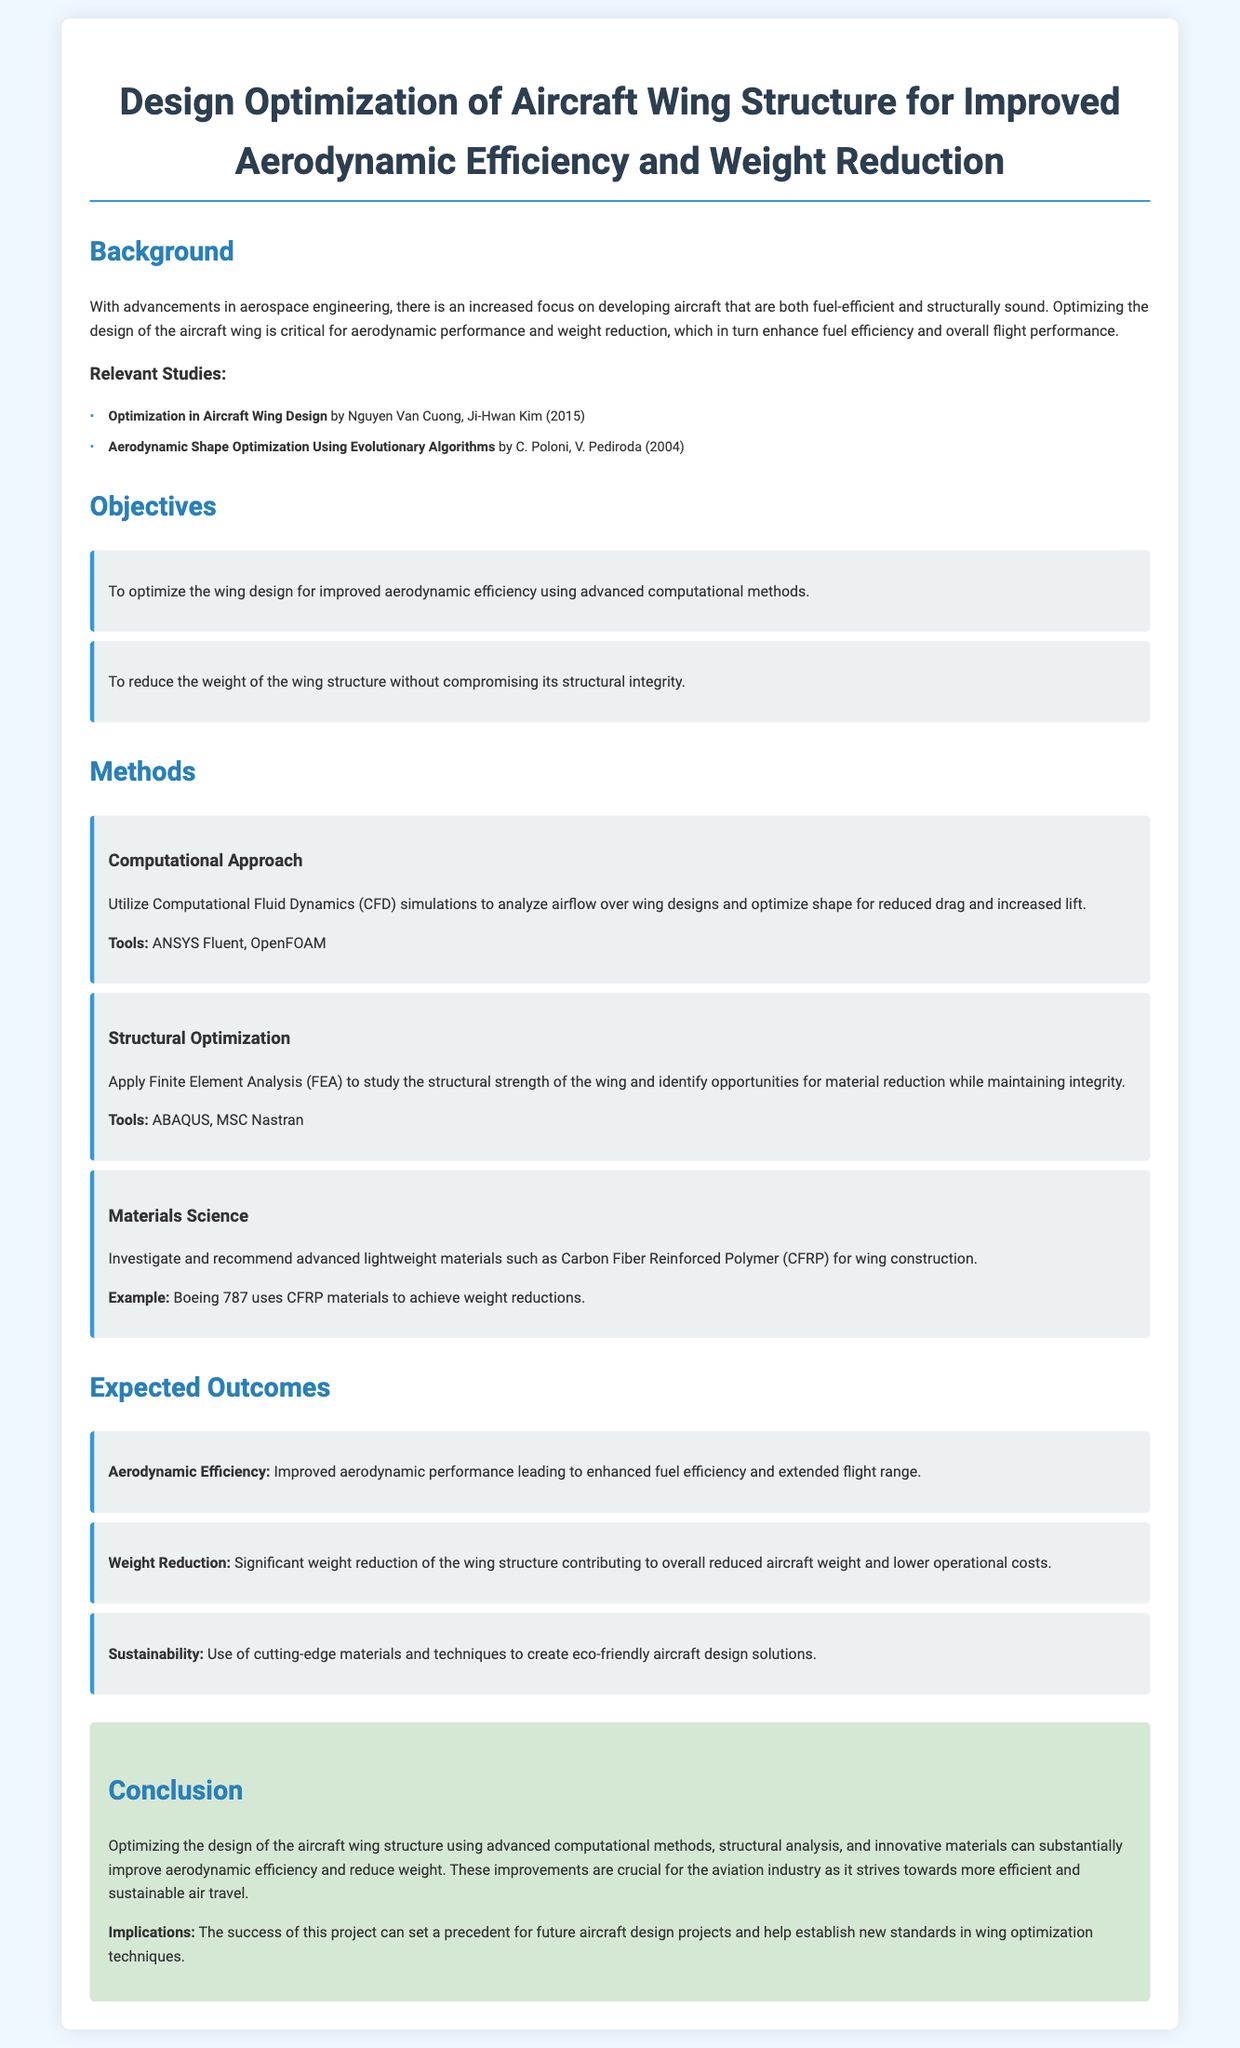What is a potential implication of the project success mentioned in the conclusion? The conclusion discusses the broader impact of the project on future designs and standards.
Answer: Set a precedent for future aircraft design projects 